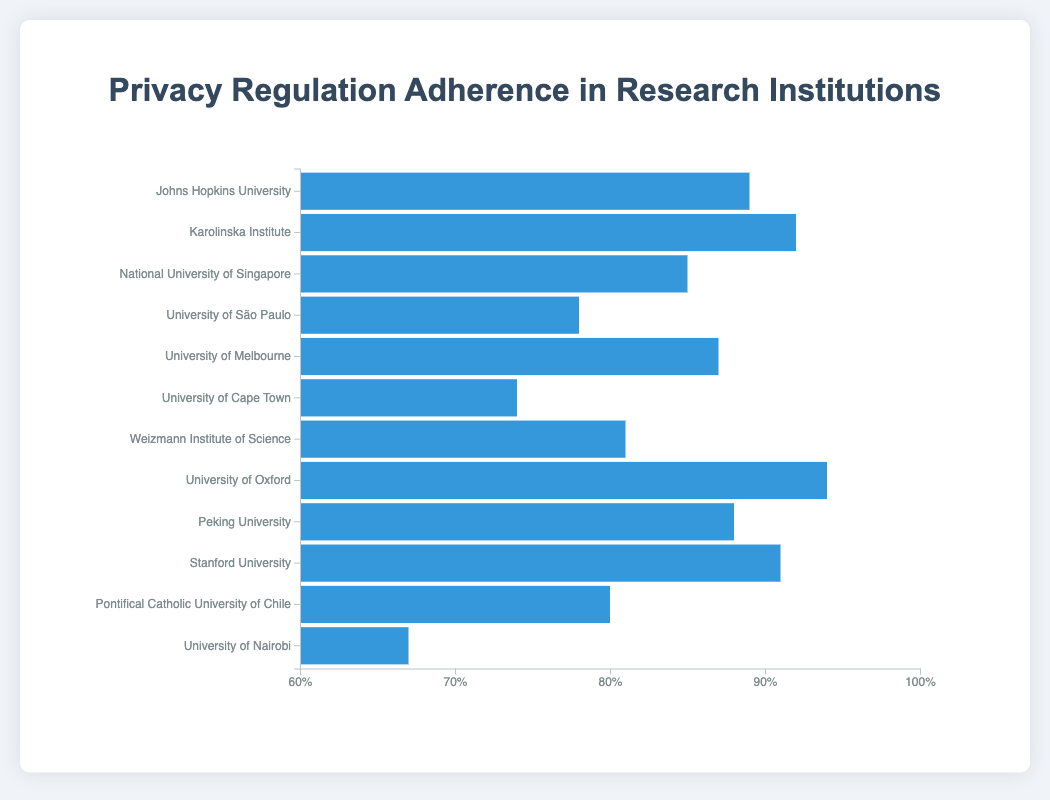What is the institution with the highest adherence rate to privacy regulations? The highest adherence rate is the longest bar in the chart. The University of Oxford has the longest bar with a 94% adherence rate.
Answer: University of Oxford Which region has the widest variation in adherence rates among its institutions? Europe has wide variation because it has institutions with adherence rates of 92% and 94%, which are close but still show the highest span within a single region.
Answer: Europe What is the average adherence rate across all institutions? Add up the adherence rates of all institutions (89 + 92 + 85 + 78 + 87 + 74 + 81 + 94 + 88 + 91 + 80 + 67) and then divide by the number of institutions (12). Total: 1006, and 1006/12 equals 83.83 (rounded).
Answer: 83.83 Which institution in Africa has the lowest adherence rate and by how much is it lower than the highest adherence rate in Europe? In Africa, the University of Nairobi has the lowest rate of 67%, and in Europe, the University of Oxford has the highest rate of 94%. The difference is 94 - 67 = 27%.
Answer: University of Nairobi, 27% Compare the adherence rates of the top institutions in North America and Asia, and state the difference? The top institution in North America is Stanford University with 91%, and in Asia, it is Peking University with 88%. The difference is 91 - 88 = 3%.
Answer: 3% Which institution has the lowest adherence rate and what is that rate? The shortest bar represents the lowest adherence rate. The University of Nairobi has the shortest bar with a 67% adherence rate.
Answer: University of Nairobi, 67% How many institutions have an adherence rate above 90%? Find bars with values above 90%. The institutions are Karolinska Institute (92%), University of Oxford (94%), and Stanford University (91%), totaling 3 institutions.
Answer: 3 What is the median adherence rate of all the institutions? List all adherence rates in ascending order and find the middle value(s). Rates: 67, 74, 78, 80, 81, 85, 87, 88, 89, 91, 92, 94. The median is the average of the 6th and 7th values (85 and 87). Median: (85 + 87) / 2 = 86.
Answer: 86 Which region has the highest and lowest average adherence rates? Compute average adherence rates for institutions in each region. 
North America: (89 + 91)/2 = 90. 
Europe: (92 + 94)/2 = 93.
Asia: (85 + 88)/2 = 86.5.
South America: (78 + 80)/2 = 79.
Australia: 87.
Africa: (74 + 67)/2 = 70.5.
Middle East: 81.
Highest is Europe (93) and Lowest is Africa (70.5).
Answer: Europe, Africa 